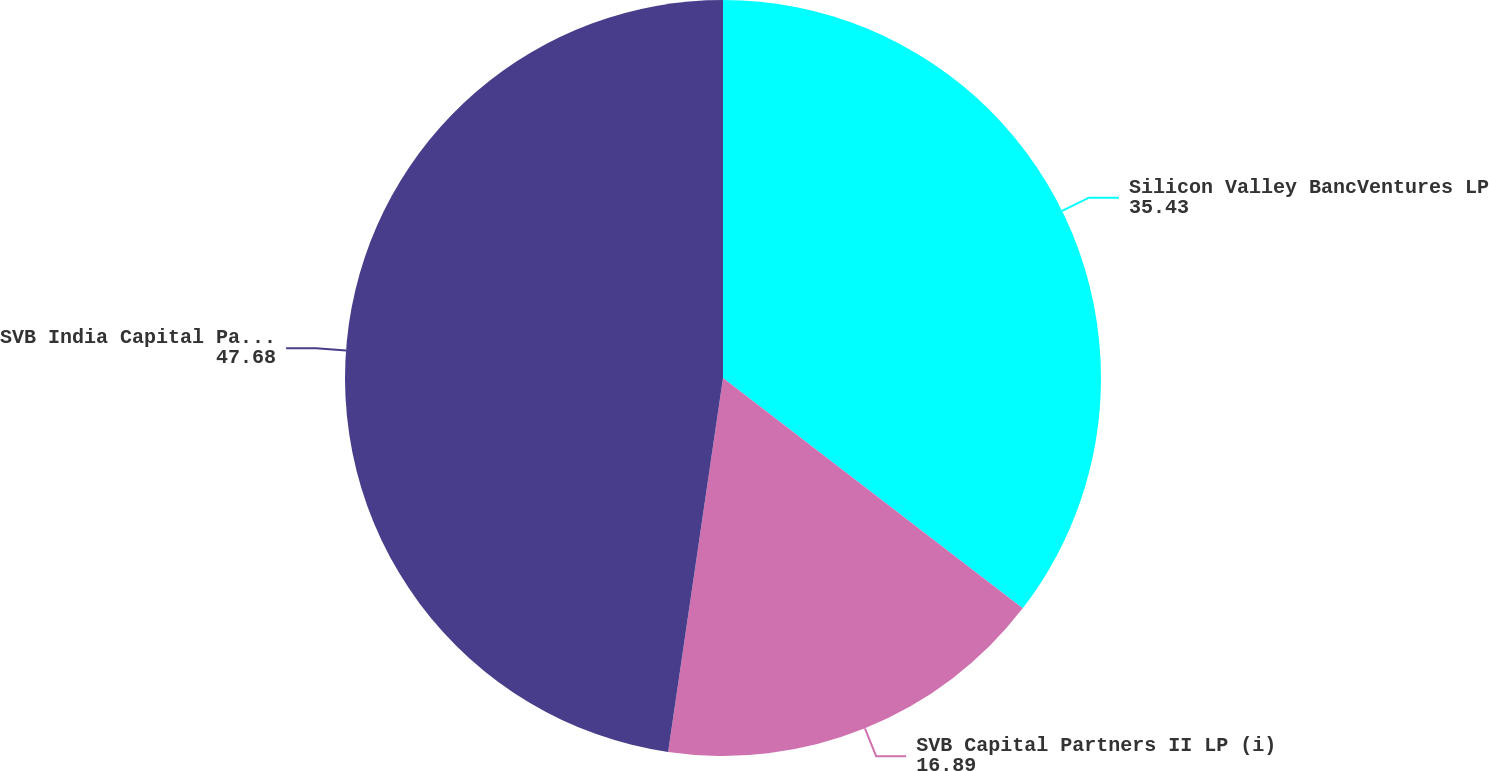Convert chart. <chart><loc_0><loc_0><loc_500><loc_500><pie_chart><fcel>Silicon Valley BancVentures LP<fcel>SVB Capital Partners II LP (i)<fcel>SVB India Capital Partners I<nl><fcel>35.43%<fcel>16.89%<fcel>47.68%<nl></chart> 